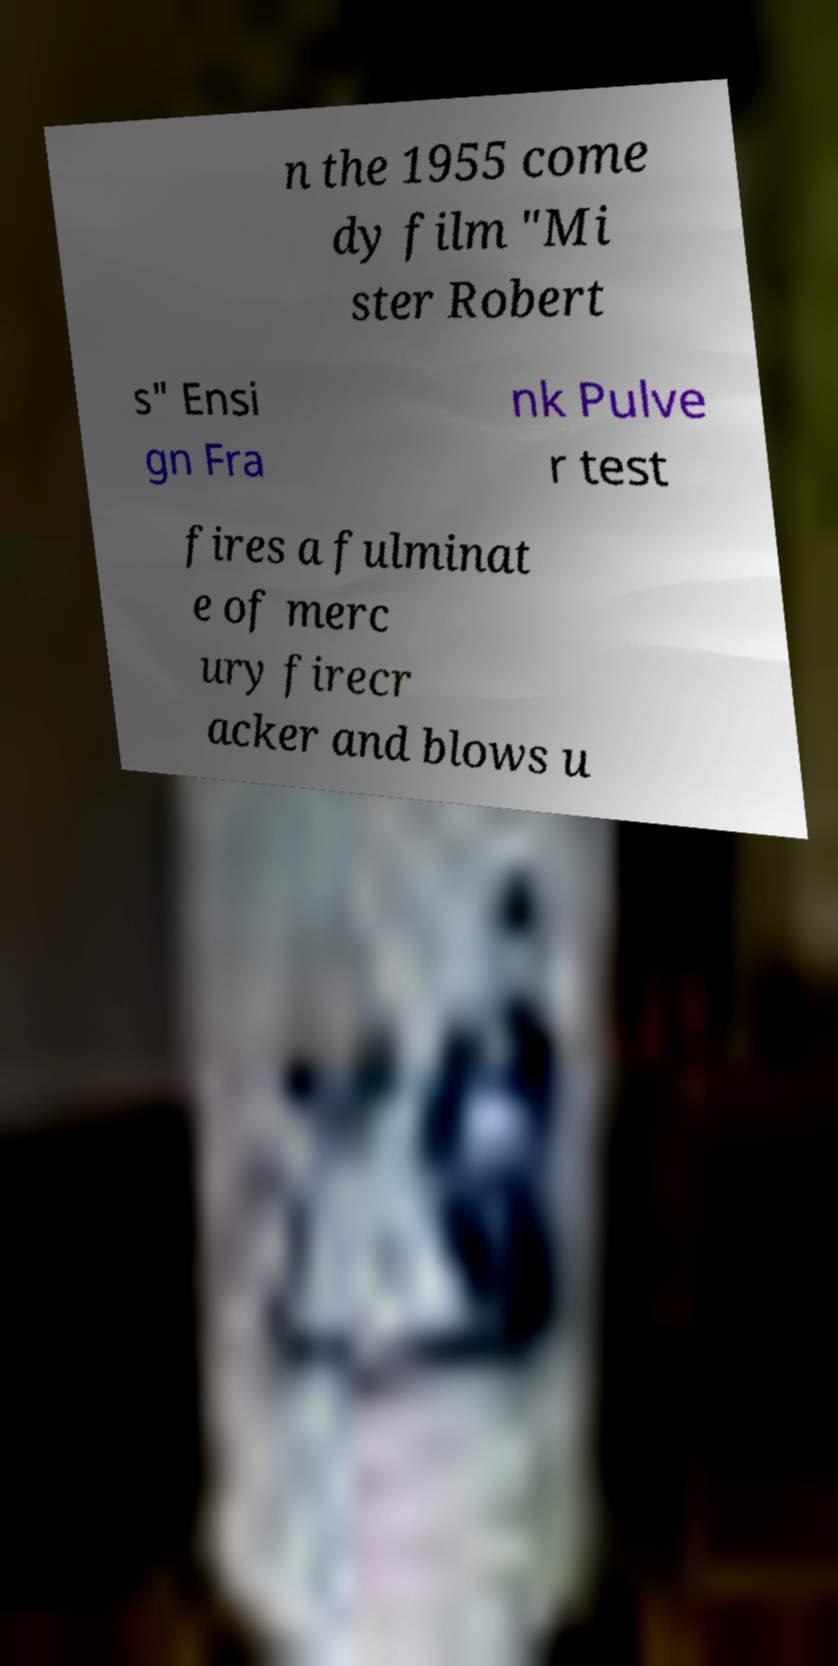Can you accurately transcribe the text from the provided image for me? n the 1955 come dy film "Mi ster Robert s" Ensi gn Fra nk Pulve r test fires a fulminat e of merc ury firecr acker and blows u 